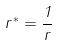Convert formula to latex. <formula><loc_0><loc_0><loc_500><loc_500>r ^ { * } = \frac { 1 } { r }</formula> 